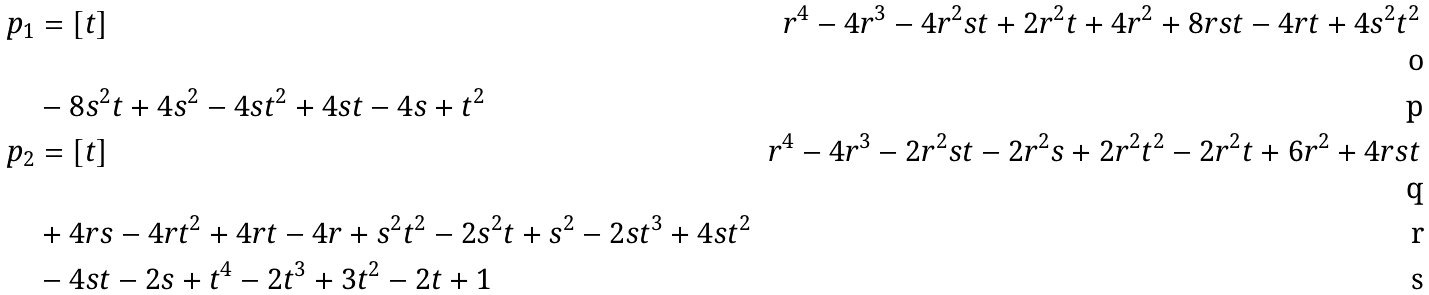Convert formula to latex. <formula><loc_0><loc_0><loc_500><loc_500>p _ { 1 } & = [ t ] & r ^ { 4 } - 4 r ^ { 3 } - 4 r ^ { 2 } s t + 2 r ^ { 2 } t + 4 r ^ { 2 } + 8 r s t - 4 r t + 4 s ^ { 2 } t ^ { 2 } \\ & - 8 s ^ { 2 } t + 4 s ^ { 2 } - 4 s t ^ { 2 } + 4 s t - 4 s + t ^ { 2 } \\ p _ { 2 } & = [ t ] & r ^ { 4 } - 4 r ^ { 3 } - 2 r ^ { 2 } s t - 2 r ^ { 2 } s + 2 r ^ { 2 } t ^ { 2 } - 2 r ^ { 2 } t + 6 r ^ { 2 } + 4 r s t \\ & + 4 r s - 4 r t ^ { 2 } + 4 r t - 4 r + s ^ { 2 } t ^ { 2 } - 2 s ^ { 2 } t + s ^ { 2 } - 2 s t ^ { 3 } + 4 s t ^ { 2 } \\ & - 4 s t - 2 s + t ^ { 4 } - 2 t ^ { 3 } + 3 t ^ { 2 } - 2 t + 1</formula> 